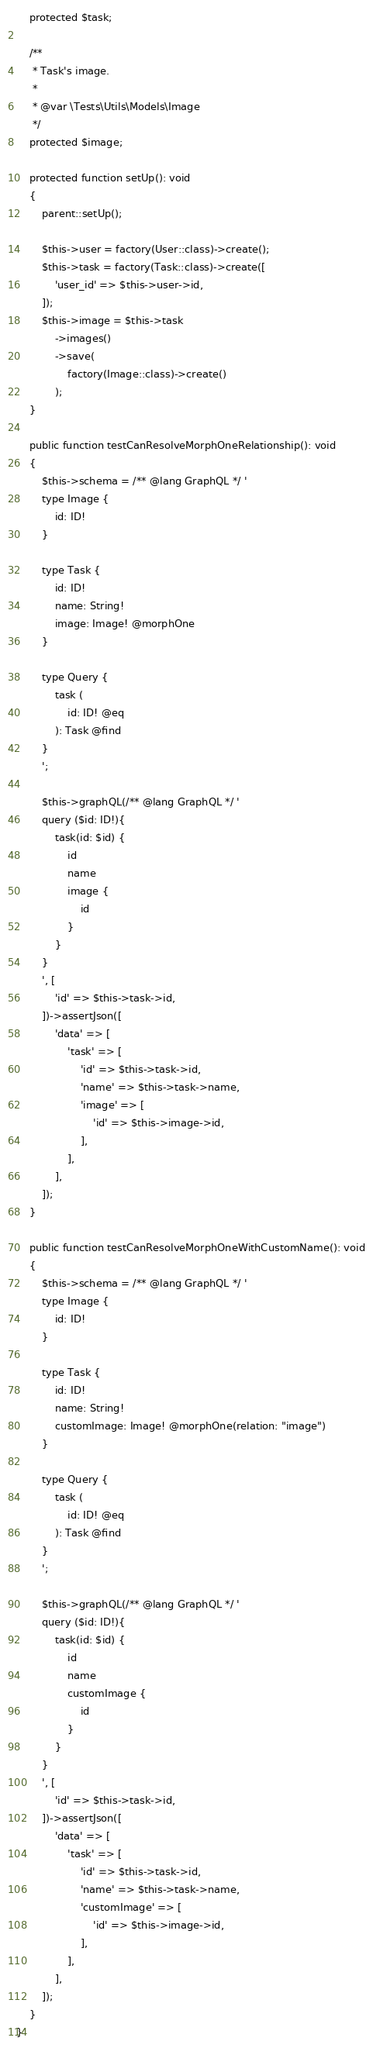Convert code to text. <code><loc_0><loc_0><loc_500><loc_500><_PHP_>    protected $task;

    /**
     * Task's image.
     *
     * @var \Tests\Utils\Models\Image
     */
    protected $image;

    protected function setUp(): void
    {
        parent::setUp();

        $this->user = factory(User::class)->create();
        $this->task = factory(Task::class)->create([
            'user_id' => $this->user->id,
        ]);
        $this->image = $this->task
            ->images()
            ->save(
                factory(Image::class)->create()
            );
    }

    public function testCanResolveMorphOneRelationship(): void
    {
        $this->schema = /** @lang GraphQL */ '
        type Image {
            id: ID!
        }

        type Task {
            id: ID!
            name: String!
            image: Image! @morphOne
        }

        type Query {
            task (
                id: ID! @eq
            ): Task @find
        }
        ';

        $this->graphQL(/** @lang GraphQL */ '
        query ($id: ID!){
            task(id: $id) {
                id
                name
                image {
                    id
                }
            }
        }
        ', [
            'id' => $this->task->id,
        ])->assertJson([
            'data' => [
                'task' => [
                    'id' => $this->task->id,
                    'name' => $this->task->name,
                    'image' => [
                        'id' => $this->image->id,
                    ],
                ],
            ],
        ]);
    }

    public function testCanResolveMorphOneWithCustomName(): void
    {
        $this->schema = /** @lang GraphQL */ '
        type Image {
            id: ID!
        }

        type Task {
            id: ID!
            name: String!
            customImage: Image! @morphOne(relation: "image")
        }

        type Query {
            task (
                id: ID! @eq
            ): Task @find
        }
        ';

        $this->graphQL(/** @lang GraphQL */ '
        query ($id: ID!){
            task(id: $id) {
                id
                name
                customImage {
                    id
                }
            }
        }
        ', [
            'id' => $this->task->id,
        ])->assertJson([
            'data' => [
                'task' => [
                    'id' => $this->task->id,
                    'name' => $this->task->name,
                    'customImage' => [
                        'id' => $this->image->id,
                    ],
                ],
            ],
        ]);
    }
}
</code> 